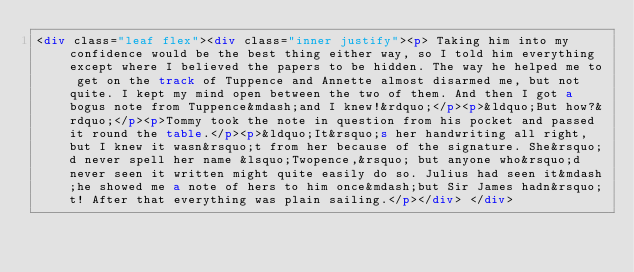Convert code to text. <code><loc_0><loc_0><loc_500><loc_500><_HTML_><div class="leaf flex"><div class="inner justify"><p> Taking him into my confidence would be the best thing either way, so I told him everything except where I believed the papers to be hidden. The way he helped me to get on the track of Tuppence and Annette almost disarmed me, but not quite. I kept my mind open between the two of them. And then I got a bogus note from Tuppence&mdash;and I knew!&rdquo;</p><p>&ldquo;But how?&rdquo;</p><p>Tommy took the note in question from his pocket and passed it round the table.</p><p>&ldquo;It&rsquo;s her handwriting all right, but I knew it wasn&rsquo;t from her because of the signature. She&rsquo;d never spell her name &lsquo;Twopence,&rsquo; but anyone who&rsquo;d never seen it written might quite easily do so. Julius had seen it&mdash;he showed me a note of hers to him once&mdash;but Sir James hadn&rsquo;t! After that everything was plain sailing.</p></div> </div></code> 